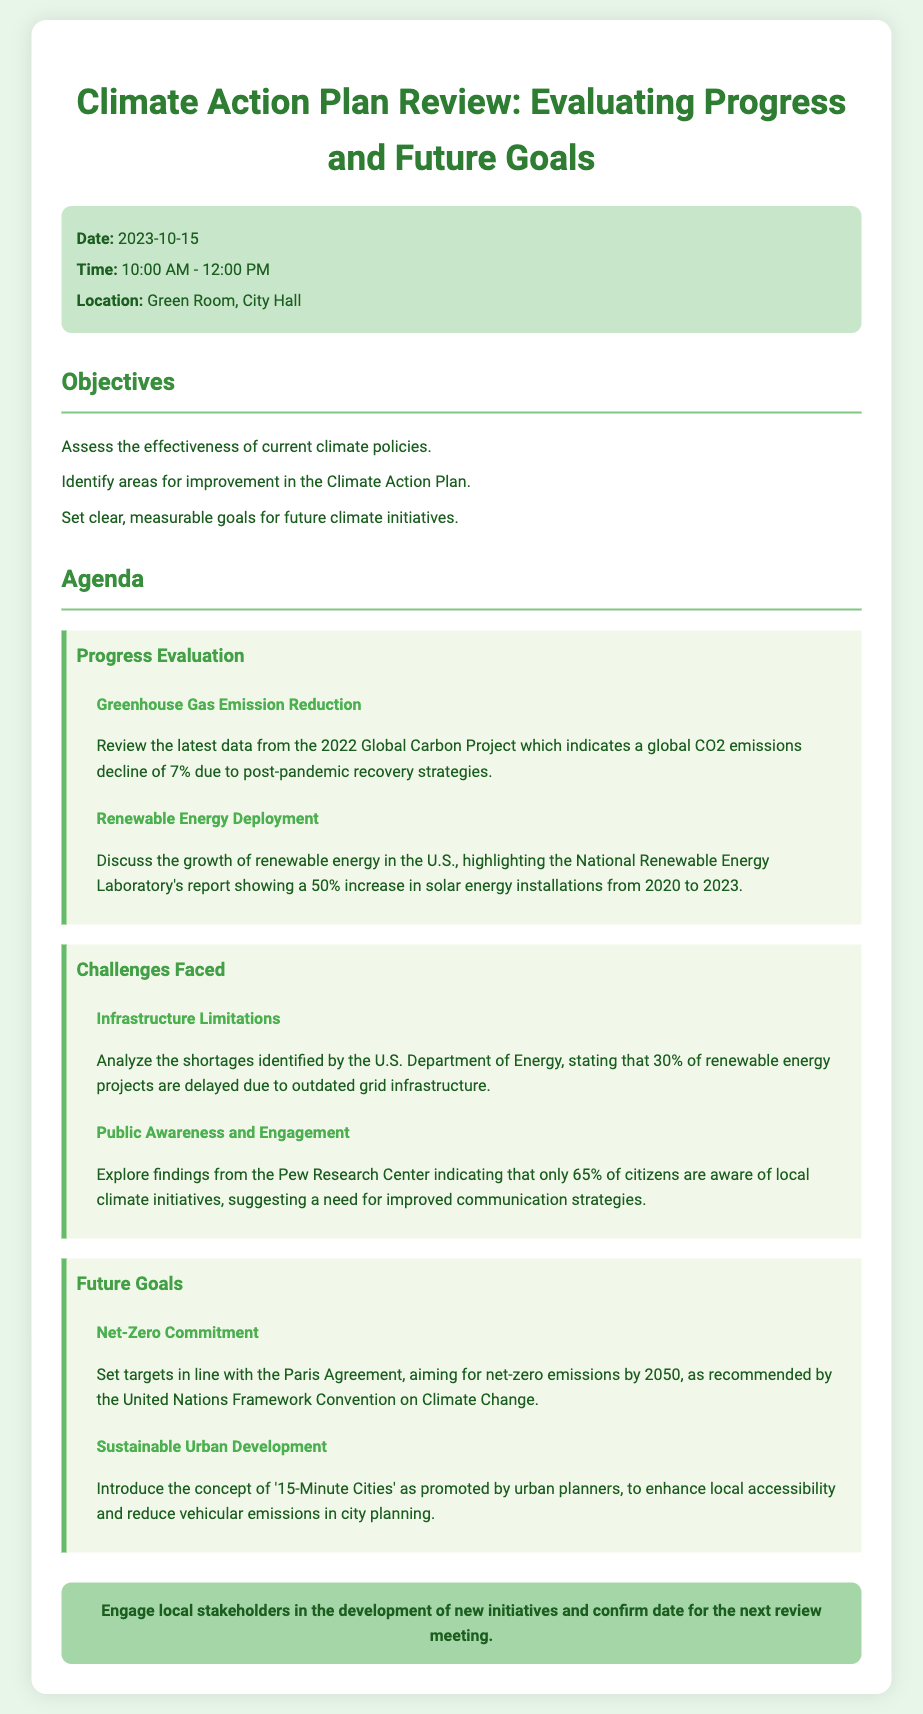What is the date of the meeting? The date of the meeting is stated clearly in the document under the info section.
Answer: 2023-10-15 What time does the meeting start? The starting time of the meeting is listed in the info section of the agenda.
Answer: 10:00 AM What is the main objective related to future climate initiatives? This objective focuses on setting clear, measurable goals for future climate initiatives.
Answer: Set clear, measurable goals What percentage of renewable energy projects are delayed due to infrastructure limitations? This percentage is provided in the discussion of challenges faced in the document.
Answer: 30% What is the target year for net-zero emissions? The target year is mentioned in the future goals section.
Answer: 2050 Which concept is introduced for sustainable urban development? This concept is highlighted in the future goals section of the agenda.
Answer: 15-Minute Cities What decline in global CO2 emissions was reported? This decline is detailed in the evaluation of progress related to greenhouse gas emissions.
Answer: 7% What is the location of the meeting? The location of the meeting is mentioned in the info section of the document.
Answer: Green Room, City Hall What is one of the findings about public awareness of climate initiatives? The finding is specified regarding citizen awareness levels.
Answer: 65% 